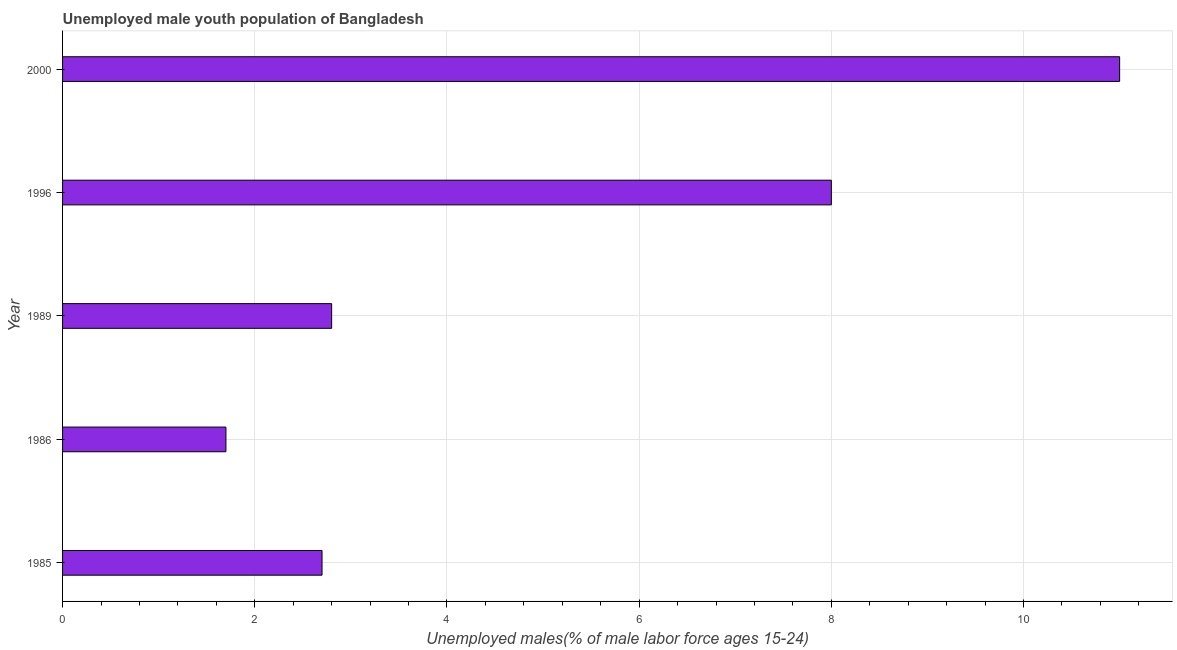What is the title of the graph?
Keep it short and to the point. Unemployed male youth population of Bangladesh. What is the label or title of the X-axis?
Offer a terse response. Unemployed males(% of male labor force ages 15-24). What is the label or title of the Y-axis?
Provide a short and direct response. Year. Across all years, what is the minimum unemployed male youth?
Provide a short and direct response. 1.7. What is the sum of the unemployed male youth?
Give a very brief answer. 26.2. What is the average unemployed male youth per year?
Your response must be concise. 5.24. What is the median unemployed male youth?
Keep it short and to the point. 2.8. Do a majority of the years between 1986 and 1996 (inclusive) have unemployed male youth greater than 8.8 %?
Provide a short and direct response. No. What is the ratio of the unemployed male youth in 1985 to that in 1996?
Your response must be concise. 0.34. What is the difference between the highest and the second highest unemployed male youth?
Provide a succinct answer. 3. Is the sum of the unemployed male youth in 1986 and 2000 greater than the maximum unemployed male youth across all years?
Ensure brevity in your answer.  Yes. What is the difference between the highest and the lowest unemployed male youth?
Your answer should be compact. 9.3. In how many years, is the unemployed male youth greater than the average unemployed male youth taken over all years?
Offer a terse response. 2. How many bars are there?
Ensure brevity in your answer.  5. Are all the bars in the graph horizontal?
Your answer should be compact. Yes. What is the difference between two consecutive major ticks on the X-axis?
Offer a very short reply. 2. What is the Unemployed males(% of male labor force ages 15-24) of 1985?
Keep it short and to the point. 2.7. What is the Unemployed males(% of male labor force ages 15-24) in 1986?
Keep it short and to the point. 1.7. What is the Unemployed males(% of male labor force ages 15-24) of 1989?
Your answer should be very brief. 2.8. What is the Unemployed males(% of male labor force ages 15-24) in 2000?
Provide a succinct answer. 11. What is the difference between the Unemployed males(% of male labor force ages 15-24) in 1985 and 1986?
Offer a very short reply. 1. What is the difference between the Unemployed males(% of male labor force ages 15-24) in 1986 and 1996?
Ensure brevity in your answer.  -6.3. What is the difference between the Unemployed males(% of male labor force ages 15-24) in 1986 and 2000?
Give a very brief answer. -9.3. What is the difference between the Unemployed males(% of male labor force ages 15-24) in 1989 and 1996?
Your answer should be compact. -5.2. What is the difference between the Unemployed males(% of male labor force ages 15-24) in 1989 and 2000?
Provide a short and direct response. -8.2. What is the ratio of the Unemployed males(% of male labor force ages 15-24) in 1985 to that in 1986?
Provide a succinct answer. 1.59. What is the ratio of the Unemployed males(% of male labor force ages 15-24) in 1985 to that in 1996?
Provide a succinct answer. 0.34. What is the ratio of the Unemployed males(% of male labor force ages 15-24) in 1985 to that in 2000?
Offer a very short reply. 0.24. What is the ratio of the Unemployed males(% of male labor force ages 15-24) in 1986 to that in 1989?
Ensure brevity in your answer.  0.61. What is the ratio of the Unemployed males(% of male labor force ages 15-24) in 1986 to that in 1996?
Keep it short and to the point. 0.21. What is the ratio of the Unemployed males(% of male labor force ages 15-24) in 1986 to that in 2000?
Make the answer very short. 0.15. What is the ratio of the Unemployed males(% of male labor force ages 15-24) in 1989 to that in 1996?
Provide a short and direct response. 0.35. What is the ratio of the Unemployed males(% of male labor force ages 15-24) in 1989 to that in 2000?
Your answer should be very brief. 0.26. What is the ratio of the Unemployed males(% of male labor force ages 15-24) in 1996 to that in 2000?
Make the answer very short. 0.73. 